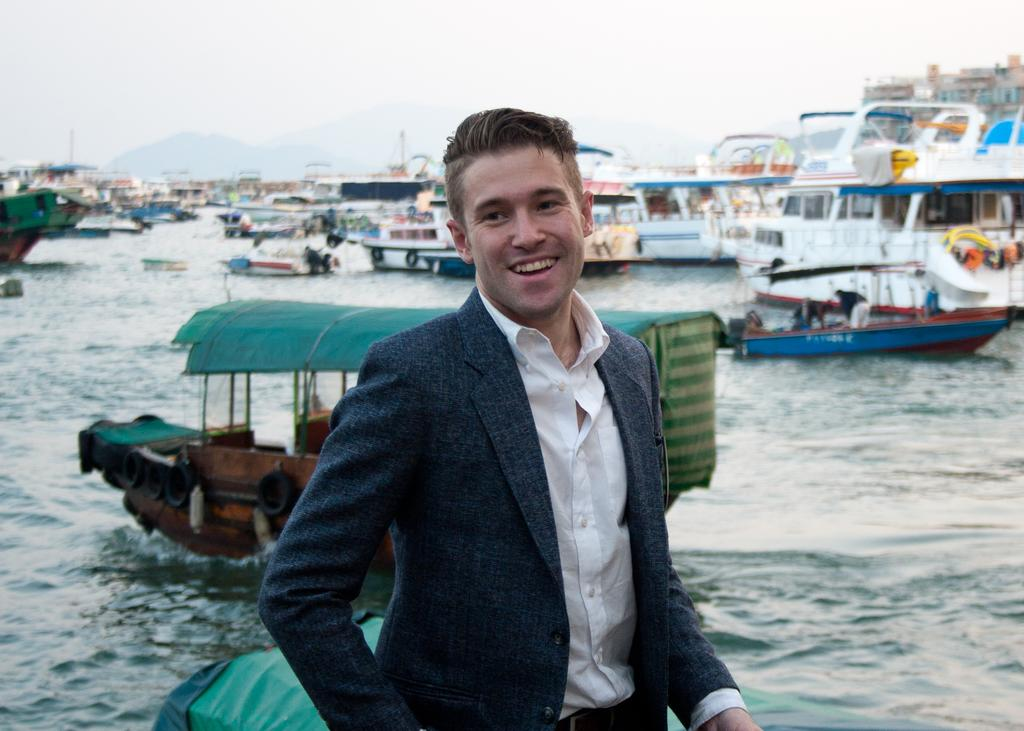Who is present in the image? There is a man in the image. What is the man's facial expression? The man is smiling. What can be seen in the background of the image? There is water visible in the image, with ships and boats on it. What is visible at the top of the image? The sky is visible at the top of the image. What language is being spoken by the man in the image during the rainstorm? There is no rainstorm present in the image, and no indication of what language the man might be speaking. 